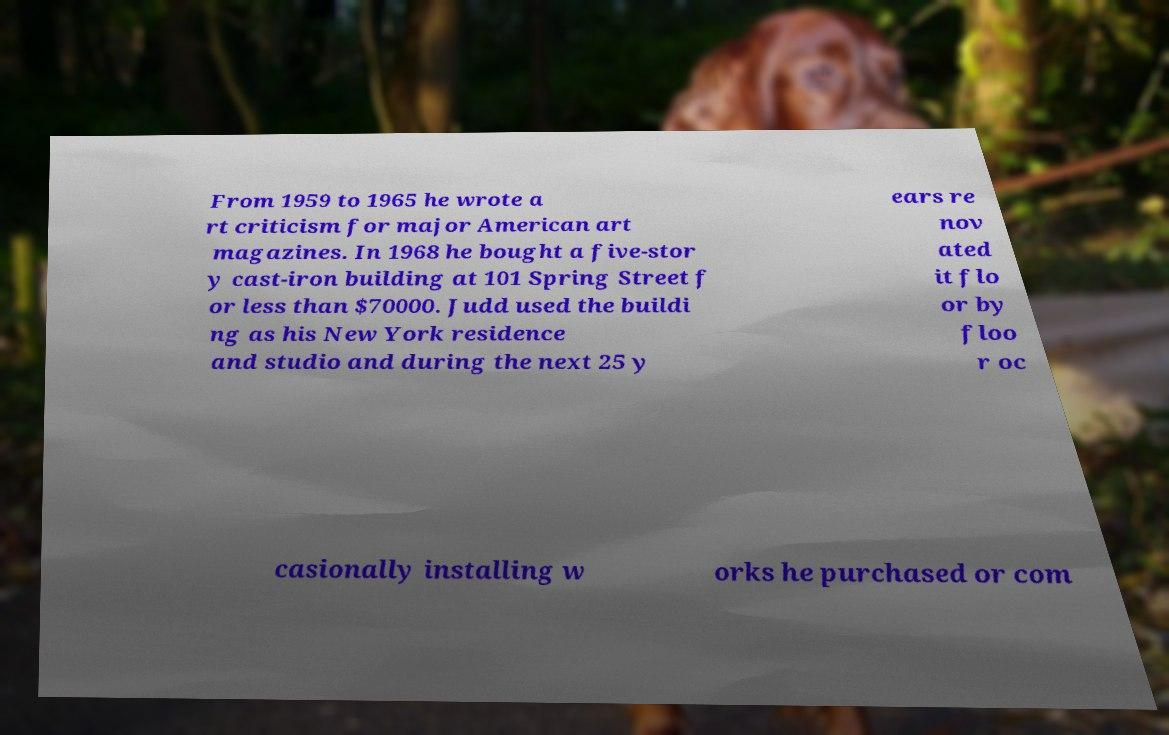I need the written content from this picture converted into text. Can you do that? From 1959 to 1965 he wrote a rt criticism for major American art magazines. In 1968 he bought a five-stor y cast-iron building at 101 Spring Street f or less than $70000. Judd used the buildi ng as his New York residence and studio and during the next 25 y ears re nov ated it flo or by floo r oc casionally installing w orks he purchased or com 